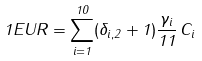<formula> <loc_0><loc_0><loc_500><loc_500>1 E U R = \sum _ { i = 1 } ^ { 1 0 } ( \delta _ { i , 2 } + 1 ) \frac { \gamma _ { i } } { 1 1 } \, C _ { i }</formula> 